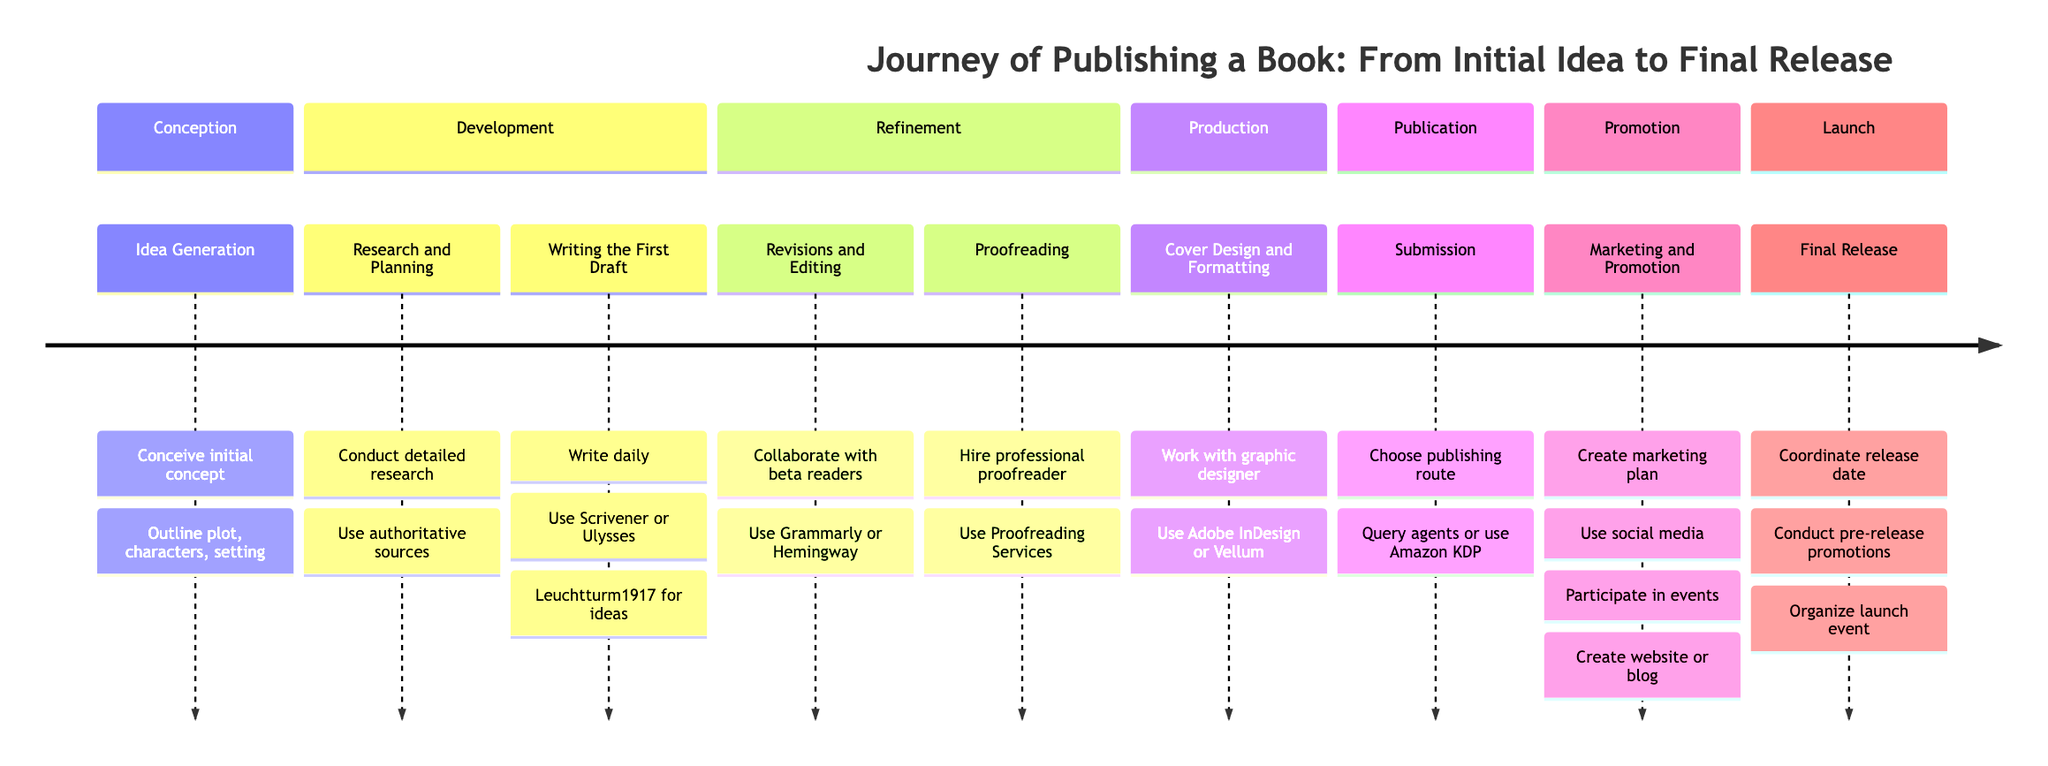What is the first stage in the publishing timeline? The timeline clearly lists "Idea Generation" as the first stage at the top of the diagram.
Answer: Idea Generation How many stages are there in total? By counting each distinct stage outlined in the timeline, we see that there are a total of eight stages.
Answer: 8 Which stage involves hiring a professional? The stage labeled "Proofreading" mentions hiring a professional proofreader to catch errors.
Answer: Proofreading What tools are recommended for writing the first draft? The "Writing the First Draft" section specifically mentions using "Scrivener or Ulysses" for organization.
Answer: Scrivener or Ulysses In which section would you find the cover design process? The "Cover Design and Formatting" is located under the "Production" section, which depicts the graphical aspect of publishing.
Answer: Production Which stage requires collaboration with beta readers? The "Revisions and Editing" stage states the need for collaboration with beta readers for feedback on the manuscript.
Answer: Revisions and Editing What document precedes the final release? Before the final release stage, the "Submission to Publishers or Self-Publishing" stage must be completed, as you must choose your publishing path.
Answer: Submission to Publishers or Self-Publishing What type of marketing does the timeline suggest? The "Marketing and Promotion" stage indicates that creating a marketing plan is crucial, along with using social media.
Answer: Marketing plan What action is suggested for generating excitement before the release? The timeline suggests conducting "pre-release promotions" in the "Final Release" section to build anticipation for the book.
Answer: Pre-release promotions 